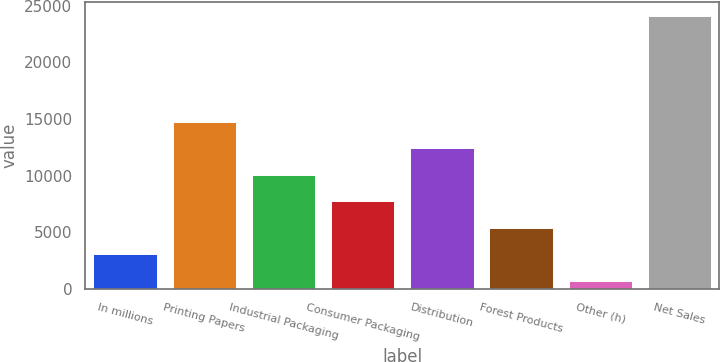<chart> <loc_0><loc_0><loc_500><loc_500><bar_chart><fcel>In millions<fcel>Printing Papers<fcel>Industrial Packaging<fcel>Consumer Packaging<fcel>Distribution<fcel>Forest Products<fcel>Other (h)<fcel>Net Sales<nl><fcel>3040.6<fcel>14738.6<fcel>10059.4<fcel>7719.8<fcel>12399<fcel>5380.2<fcel>701<fcel>24097<nl></chart> 